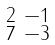Convert formula to latex. <formula><loc_0><loc_0><loc_500><loc_500>\begin{smallmatrix} 2 & - 1 \\ 7 & - 3 \end{smallmatrix}</formula> 